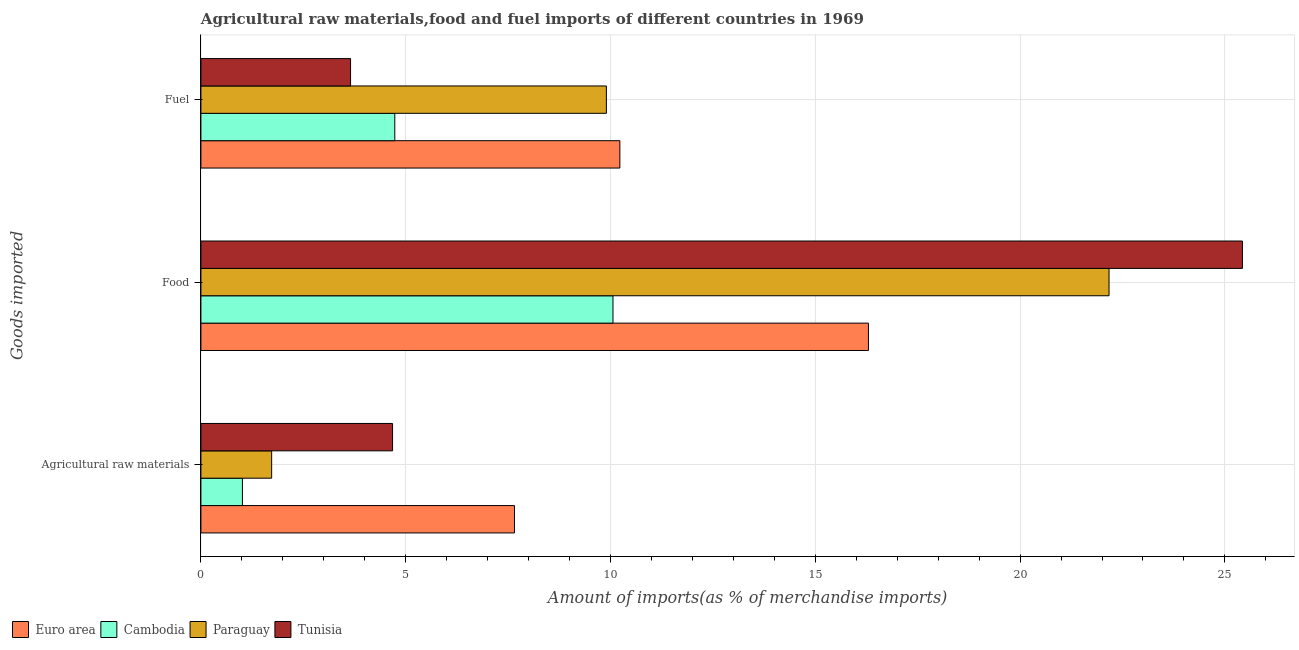How many groups of bars are there?
Your answer should be very brief. 3. Are the number of bars per tick equal to the number of legend labels?
Keep it short and to the point. Yes. Are the number of bars on each tick of the Y-axis equal?
Keep it short and to the point. Yes. How many bars are there on the 2nd tick from the top?
Provide a succinct answer. 4. What is the label of the 3rd group of bars from the top?
Provide a succinct answer. Agricultural raw materials. What is the percentage of raw materials imports in Cambodia?
Keep it short and to the point. 1.01. Across all countries, what is the maximum percentage of food imports?
Provide a short and direct response. 25.43. Across all countries, what is the minimum percentage of food imports?
Your answer should be compact. 10.06. In which country was the percentage of raw materials imports maximum?
Provide a short and direct response. Euro area. In which country was the percentage of raw materials imports minimum?
Give a very brief answer. Cambodia. What is the total percentage of fuel imports in the graph?
Keep it short and to the point. 28.52. What is the difference between the percentage of fuel imports in Cambodia and that in Tunisia?
Make the answer very short. 1.08. What is the difference between the percentage of raw materials imports in Cambodia and the percentage of food imports in Euro area?
Your answer should be very brief. -15.28. What is the average percentage of fuel imports per country?
Offer a terse response. 7.13. What is the difference between the percentage of fuel imports and percentage of food imports in Euro area?
Give a very brief answer. -6.07. What is the ratio of the percentage of food imports in Cambodia to that in Paraguay?
Give a very brief answer. 0.45. Is the percentage of food imports in Euro area less than that in Paraguay?
Offer a terse response. Yes. Is the difference between the percentage of raw materials imports in Paraguay and Cambodia greater than the difference between the percentage of food imports in Paraguay and Cambodia?
Your answer should be very brief. No. What is the difference between the highest and the second highest percentage of fuel imports?
Provide a succinct answer. 0.33. What is the difference between the highest and the lowest percentage of raw materials imports?
Provide a succinct answer. 6.64. In how many countries, is the percentage of food imports greater than the average percentage of food imports taken over all countries?
Make the answer very short. 2. Is the sum of the percentage of raw materials imports in Paraguay and Euro area greater than the maximum percentage of food imports across all countries?
Provide a succinct answer. No. What does the 3rd bar from the bottom in Food represents?
Offer a very short reply. Paraguay. Are all the bars in the graph horizontal?
Ensure brevity in your answer.  Yes. How many countries are there in the graph?
Your response must be concise. 4. What is the difference between two consecutive major ticks on the X-axis?
Offer a very short reply. 5. Does the graph contain any zero values?
Make the answer very short. No. How are the legend labels stacked?
Offer a very short reply. Horizontal. What is the title of the graph?
Give a very brief answer. Agricultural raw materials,food and fuel imports of different countries in 1969. Does "Pakistan" appear as one of the legend labels in the graph?
Make the answer very short. No. What is the label or title of the X-axis?
Your answer should be very brief. Amount of imports(as % of merchandise imports). What is the label or title of the Y-axis?
Provide a short and direct response. Goods imported. What is the Amount of imports(as % of merchandise imports) of Euro area in Agricultural raw materials?
Make the answer very short. 7.66. What is the Amount of imports(as % of merchandise imports) in Cambodia in Agricultural raw materials?
Ensure brevity in your answer.  1.01. What is the Amount of imports(as % of merchandise imports) of Paraguay in Agricultural raw materials?
Provide a short and direct response. 1.73. What is the Amount of imports(as % of merchandise imports) in Tunisia in Agricultural raw materials?
Ensure brevity in your answer.  4.68. What is the Amount of imports(as % of merchandise imports) of Euro area in Food?
Provide a succinct answer. 16.3. What is the Amount of imports(as % of merchandise imports) in Cambodia in Food?
Make the answer very short. 10.06. What is the Amount of imports(as % of merchandise imports) in Paraguay in Food?
Provide a short and direct response. 22.17. What is the Amount of imports(as % of merchandise imports) in Tunisia in Food?
Give a very brief answer. 25.43. What is the Amount of imports(as % of merchandise imports) of Euro area in Fuel?
Give a very brief answer. 10.23. What is the Amount of imports(as % of merchandise imports) of Cambodia in Fuel?
Your answer should be very brief. 4.73. What is the Amount of imports(as % of merchandise imports) of Paraguay in Fuel?
Make the answer very short. 9.9. What is the Amount of imports(as % of merchandise imports) of Tunisia in Fuel?
Offer a very short reply. 3.65. Across all Goods imported, what is the maximum Amount of imports(as % of merchandise imports) in Euro area?
Provide a short and direct response. 16.3. Across all Goods imported, what is the maximum Amount of imports(as % of merchandise imports) of Cambodia?
Offer a terse response. 10.06. Across all Goods imported, what is the maximum Amount of imports(as % of merchandise imports) of Paraguay?
Provide a succinct answer. 22.17. Across all Goods imported, what is the maximum Amount of imports(as % of merchandise imports) of Tunisia?
Provide a succinct answer. 25.43. Across all Goods imported, what is the minimum Amount of imports(as % of merchandise imports) of Euro area?
Give a very brief answer. 7.66. Across all Goods imported, what is the minimum Amount of imports(as % of merchandise imports) in Cambodia?
Offer a very short reply. 1.01. Across all Goods imported, what is the minimum Amount of imports(as % of merchandise imports) in Paraguay?
Give a very brief answer. 1.73. Across all Goods imported, what is the minimum Amount of imports(as % of merchandise imports) of Tunisia?
Give a very brief answer. 3.65. What is the total Amount of imports(as % of merchandise imports) of Euro area in the graph?
Your answer should be very brief. 34.18. What is the total Amount of imports(as % of merchandise imports) in Cambodia in the graph?
Provide a succinct answer. 15.81. What is the total Amount of imports(as % of merchandise imports) of Paraguay in the graph?
Ensure brevity in your answer.  33.8. What is the total Amount of imports(as % of merchandise imports) of Tunisia in the graph?
Provide a succinct answer. 33.76. What is the difference between the Amount of imports(as % of merchandise imports) of Euro area in Agricultural raw materials and that in Food?
Provide a short and direct response. -8.64. What is the difference between the Amount of imports(as % of merchandise imports) of Cambodia in Agricultural raw materials and that in Food?
Offer a terse response. -9.05. What is the difference between the Amount of imports(as % of merchandise imports) in Paraguay in Agricultural raw materials and that in Food?
Provide a short and direct response. -20.44. What is the difference between the Amount of imports(as % of merchandise imports) of Tunisia in Agricultural raw materials and that in Food?
Your response must be concise. -20.75. What is the difference between the Amount of imports(as % of merchandise imports) of Euro area in Agricultural raw materials and that in Fuel?
Offer a terse response. -2.57. What is the difference between the Amount of imports(as % of merchandise imports) of Cambodia in Agricultural raw materials and that in Fuel?
Offer a very short reply. -3.72. What is the difference between the Amount of imports(as % of merchandise imports) in Paraguay in Agricultural raw materials and that in Fuel?
Offer a very short reply. -8.17. What is the difference between the Amount of imports(as % of merchandise imports) in Tunisia in Agricultural raw materials and that in Fuel?
Offer a very short reply. 1.03. What is the difference between the Amount of imports(as % of merchandise imports) in Euro area in Food and that in Fuel?
Provide a succinct answer. 6.07. What is the difference between the Amount of imports(as % of merchandise imports) of Cambodia in Food and that in Fuel?
Keep it short and to the point. 5.33. What is the difference between the Amount of imports(as % of merchandise imports) of Paraguay in Food and that in Fuel?
Your answer should be compact. 12.27. What is the difference between the Amount of imports(as % of merchandise imports) in Tunisia in Food and that in Fuel?
Your answer should be compact. 21.77. What is the difference between the Amount of imports(as % of merchandise imports) of Euro area in Agricultural raw materials and the Amount of imports(as % of merchandise imports) of Cambodia in Food?
Your response must be concise. -2.4. What is the difference between the Amount of imports(as % of merchandise imports) in Euro area in Agricultural raw materials and the Amount of imports(as % of merchandise imports) in Paraguay in Food?
Your answer should be compact. -14.52. What is the difference between the Amount of imports(as % of merchandise imports) in Euro area in Agricultural raw materials and the Amount of imports(as % of merchandise imports) in Tunisia in Food?
Your response must be concise. -17.77. What is the difference between the Amount of imports(as % of merchandise imports) in Cambodia in Agricultural raw materials and the Amount of imports(as % of merchandise imports) in Paraguay in Food?
Offer a terse response. -21.16. What is the difference between the Amount of imports(as % of merchandise imports) of Cambodia in Agricultural raw materials and the Amount of imports(as % of merchandise imports) of Tunisia in Food?
Make the answer very short. -24.41. What is the difference between the Amount of imports(as % of merchandise imports) in Paraguay in Agricultural raw materials and the Amount of imports(as % of merchandise imports) in Tunisia in Food?
Offer a very short reply. -23.7. What is the difference between the Amount of imports(as % of merchandise imports) in Euro area in Agricultural raw materials and the Amount of imports(as % of merchandise imports) in Cambodia in Fuel?
Your answer should be compact. 2.92. What is the difference between the Amount of imports(as % of merchandise imports) of Euro area in Agricultural raw materials and the Amount of imports(as % of merchandise imports) of Paraguay in Fuel?
Ensure brevity in your answer.  -2.24. What is the difference between the Amount of imports(as % of merchandise imports) of Euro area in Agricultural raw materials and the Amount of imports(as % of merchandise imports) of Tunisia in Fuel?
Ensure brevity in your answer.  4. What is the difference between the Amount of imports(as % of merchandise imports) in Cambodia in Agricultural raw materials and the Amount of imports(as % of merchandise imports) in Paraguay in Fuel?
Keep it short and to the point. -8.89. What is the difference between the Amount of imports(as % of merchandise imports) in Cambodia in Agricultural raw materials and the Amount of imports(as % of merchandise imports) in Tunisia in Fuel?
Offer a terse response. -2.64. What is the difference between the Amount of imports(as % of merchandise imports) of Paraguay in Agricultural raw materials and the Amount of imports(as % of merchandise imports) of Tunisia in Fuel?
Make the answer very short. -1.93. What is the difference between the Amount of imports(as % of merchandise imports) of Euro area in Food and the Amount of imports(as % of merchandise imports) of Cambodia in Fuel?
Provide a short and direct response. 11.56. What is the difference between the Amount of imports(as % of merchandise imports) in Euro area in Food and the Amount of imports(as % of merchandise imports) in Paraguay in Fuel?
Your answer should be compact. 6.4. What is the difference between the Amount of imports(as % of merchandise imports) in Euro area in Food and the Amount of imports(as % of merchandise imports) in Tunisia in Fuel?
Your response must be concise. 12.64. What is the difference between the Amount of imports(as % of merchandise imports) of Cambodia in Food and the Amount of imports(as % of merchandise imports) of Paraguay in Fuel?
Provide a succinct answer. 0.16. What is the difference between the Amount of imports(as % of merchandise imports) of Cambodia in Food and the Amount of imports(as % of merchandise imports) of Tunisia in Fuel?
Make the answer very short. 6.41. What is the difference between the Amount of imports(as % of merchandise imports) of Paraguay in Food and the Amount of imports(as % of merchandise imports) of Tunisia in Fuel?
Provide a short and direct response. 18.52. What is the average Amount of imports(as % of merchandise imports) in Euro area per Goods imported?
Your answer should be very brief. 11.39. What is the average Amount of imports(as % of merchandise imports) of Cambodia per Goods imported?
Make the answer very short. 5.27. What is the average Amount of imports(as % of merchandise imports) of Paraguay per Goods imported?
Your response must be concise. 11.27. What is the average Amount of imports(as % of merchandise imports) in Tunisia per Goods imported?
Provide a short and direct response. 11.25. What is the difference between the Amount of imports(as % of merchandise imports) of Euro area and Amount of imports(as % of merchandise imports) of Cambodia in Agricultural raw materials?
Provide a succinct answer. 6.64. What is the difference between the Amount of imports(as % of merchandise imports) of Euro area and Amount of imports(as % of merchandise imports) of Paraguay in Agricultural raw materials?
Offer a very short reply. 5.93. What is the difference between the Amount of imports(as % of merchandise imports) in Euro area and Amount of imports(as % of merchandise imports) in Tunisia in Agricultural raw materials?
Ensure brevity in your answer.  2.98. What is the difference between the Amount of imports(as % of merchandise imports) of Cambodia and Amount of imports(as % of merchandise imports) of Paraguay in Agricultural raw materials?
Offer a terse response. -0.71. What is the difference between the Amount of imports(as % of merchandise imports) in Cambodia and Amount of imports(as % of merchandise imports) in Tunisia in Agricultural raw materials?
Provide a succinct answer. -3.67. What is the difference between the Amount of imports(as % of merchandise imports) of Paraguay and Amount of imports(as % of merchandise imports) of Tunisia in Agricultural raw materials?
Offer a very short reply. -2.95. What is the difference between the Amount of imports(as % of merchandise imports) of Euro area and Amount of imports(as % of merchandise imports) of Cambodia in Food?
Offer a terse response. 6.24. What is the difference between the Amount of imports(as % of merchandise imports) in Euro area and Amount of imports(as % of merchandise imports) in Paraguay in Food?
Ensure brevity in your answer.  -5.87. What is the difference between the Amount of imports(as % of merchandise imports) in Euro area and Amount of imports(as % of merchandise imports) in Tunisia in Food?
Make the answer very short. -9.13. What is the difference between the Amount of imports(as % of merchandise imports) in Cambodia and Amount of imports(as % of merchandise imports) in Paraguay in Food?
Offer a very short reply. -12.11. What is the difference between the Amount of imports(as % of merchandise imports) of Cambodia and Amount of imports(as % of merchandise imports) of Tunisia in Food?
Offer a very short reply. -15.37. What is the difference between the Amount of imports(as % of merchandise imports) in Paraguay and Amount of imports(as % of merchandise imports) in Tunisia in Food?
Make the answer very short. -3.26. What is the difference between the Amount of imports(as % of merchandise imports) in Euro area and Amount of imports(as % of merchandise imports) in Cambodia in Fuel?
Keep it short and to the point. 5.49. What is the difference between the Amount of imports(as % of merchandise imports) of Euro area and Amount of imports(as % of merchandise imports) of Paraguay in Fuel?
Make the answer very short. 0.33. What is the difference between the Amount of imports(as % of merchandise imports) of Euro area and Amount of imports(as % of merchandise imports) of Tunisia in Fuel?
Make the answer very short. 6.57. What is the difference between the Amount of imports(as % of merchandise imports) in Cambodia and Amount of imports(as % of merchandise imports) in Paraguay in Fuel?
Offer a terse response. -5.17. What is the difference between the Amount of imports(as % of merchandise imports) of Paraguay and Amount of imports(as % of merchandise imports) of Tunisia in Fuel?
Your answer should be very brief. 6.25. What is the ratio of the Amount of imports(as % of merchandise imports) in Euro area in Agricultural raw materials to that in Food?
Make the answer very short. 0.47. What is the ratio of the Amount of imports(as % of merchandise imports) of Cambodia in Agricultural raw materials to that in Food?
Offer a terse response. 0.1. What is the ratio of the Amount of imports(as % of merchandise imports) in Paraguay in Agricultural raw materials to that in Food?
Give a very brief answer. 0.08. What is the ratio of the Amount of imports(as % of merchandise imports) of Tunisia in Agricultural raw materials to that in Food?
Give a very brief answer. 0.18. What is the ratio of the Amount of imports(as % of merchandise imports) in Euro area in Agricultural raw materials to that in Fuel?
Your response must be concise. 0.75. What is the ratio of the Amount of imports(as % of merchandise imports) of Cambodia in Agricultural raw materials to that in Fuel?
Offer a very short reply. 0.21. What is the ratio of the Amount of imports(as % of merchandise imports) of Paraguay in Agricultural raw materials to that in Fuel?
Offer a very short reply. 0.17. What is the ratio of the Amount of imports(as % of merchandise imports) in Tunisia in Agricultural raw materials to that in Fuel?
Provide a succinct answer. 1.28. What is the ratio of the Amount of imports(as % of merchandise imports) in Euro area in Food to that in Fuel?
Provide a short and direct response. 1.59. What is the ratio of the Amount of imports(as % of merchandise imports) of Cambodia in Food to that in Fuel?
Give a very brief answer. 2.13. What is the ratio of the Amount of imports(as % of merchandise imports) in Paraguay in Food to that in Fuel?
Give a very brief answer. 2.24. What is the ratio of the Amount of imports(as % of merchandise imports) in Tunisia in Food to that in Fuel?
Give a very brief answer. 6.96. What is the difference between the highest and the second highest Amount of imports(as % of merchandise imports) in Euro area?
Your answer should be compact. 6.07. What is the difference between the highest and the second highest Amount of imports(as % of merchandise imports) of Cambodia?
Make the answer very short. 5.33. What is the difference between the highest and the second highest Amount of imports(as % of merchandise imports) in Paraguay?
Your answer should be compact. 12.27. What is the difference between the highest and the second highest Amount of imports(as % of merchandise imports) of Tunisia?
Ensure brevity in your answer.  20.75. What is the difference between the highest and the lowest Amount of imports(as % of merchandise imports) of Euro area?
Make the answer very short. 8.64. What is the difference between the highest and the lowest Amount of imports(as % of merchandise imports) in Cambodia?
Provide a short and direct response. 9.05. What is the difference between the highest and the lowest Amount of imports(as % of merchandise imports) of Paraguay?
Offer a terse response. 20.44. What is the difference between the highest and the lowest Amount of imports(as % of merchandise imports) in Tunisia?
Your response must be concise. 21.77. 